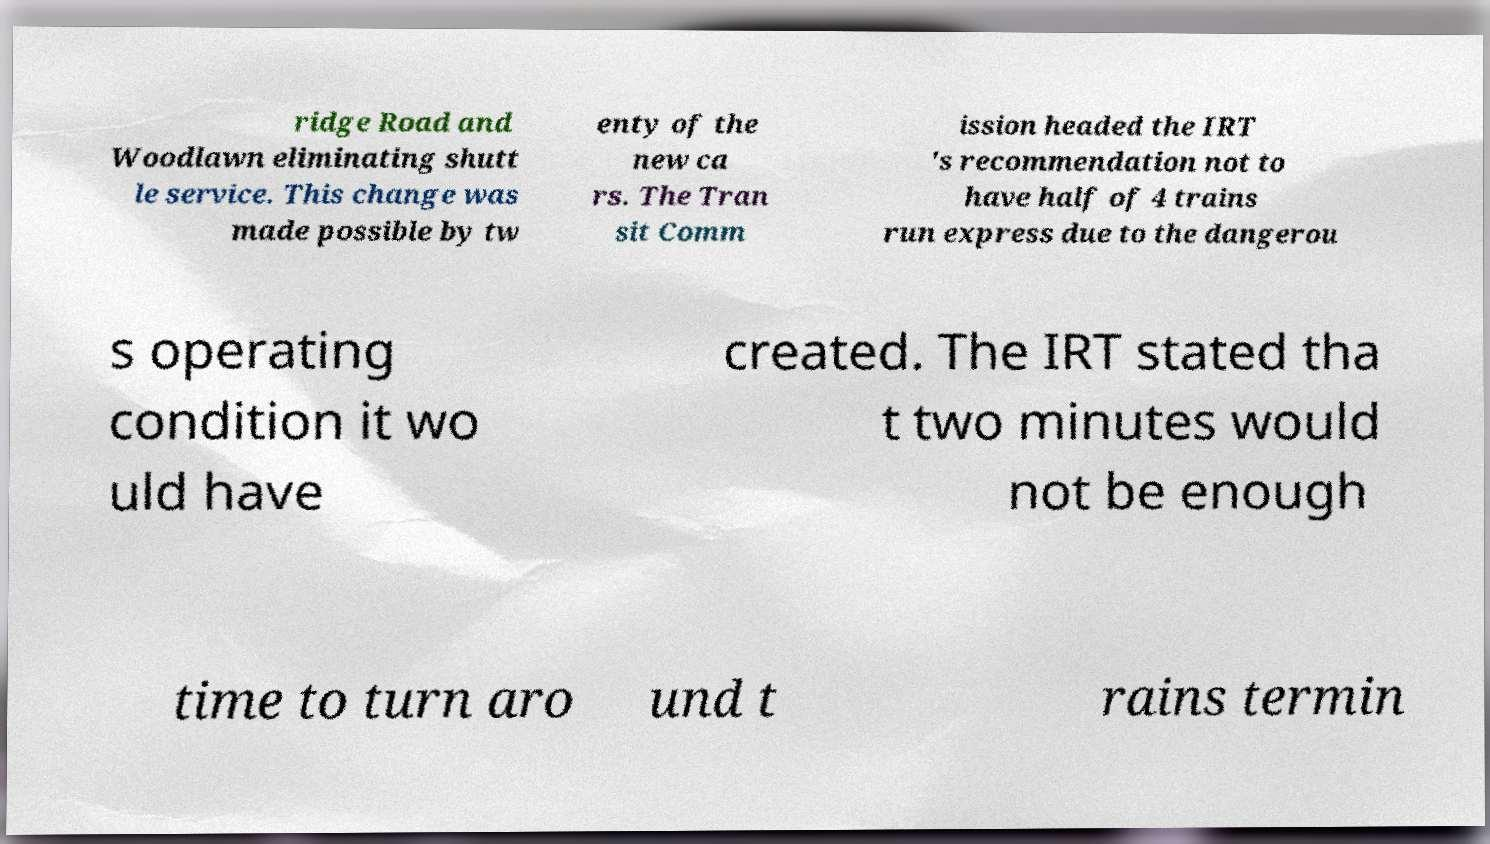Can you read and provide the text displayed in the image?This photo seems to have some interesting text. Can you extract and type it out for me? ridge Road and Woodlawn eliminating shutt le service. This change was made possible by tw enty of the new ca rs. The Tran sit Comm ission headed the IRT 's recommendation not to have half of 4 trains run express due to the dangerou s operating condition it wo uld have created. The IRT stated tha t two minutes would not be enough time to turn aro und t rains termin 